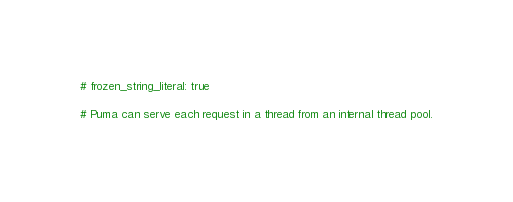<code> <loc_0><loc_0><loc_500><loc_500><_Ruby_># frozen_string_literal: true

# Puma can serve each request in a thread from an internal thread pool.</code> 